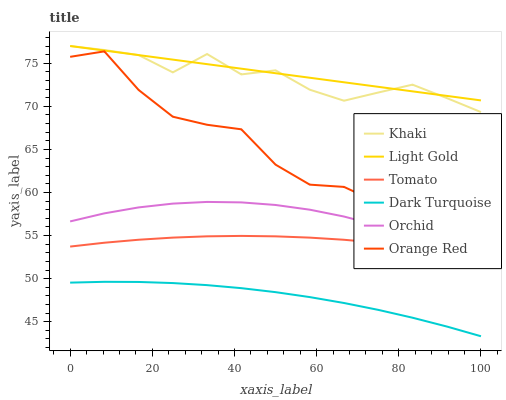Does Dark Turquoise have the minimum area under the curve?
Answer yes or no. Yes. Does Light Gold have the maximum area under the curve?
Answer yes or no. Yes. Does Khaki have the minimum area under the curve?
Answer yes or no. No. Does Khaki have the maximum area under the curve?
Answer yes or no. No. Is Light Gold the smoothest?
Answer yes or no. Yes. Is Orange Red the roughest?
Answer yes or no. Yes. Is Khaki the smoothest?
Answer yes or no. No. Is Khaki the roughest?
Answer yes or no. No. Does Dark Turquoise have the lowest value?
Answer yes or no. Yes. Does Khaki have the lowest value?
Answer yes or no. No. Does Light Gold have the highest value?
Answer yes or no. Yes. Does Dark Turquoise have the highest value?
Answer yes or no. No. Is Orchid less than Khaki?
Answer yes or no. Yes. Is Orange Red greater than Dark Turquoise?
Answer yes or no. Yes. Does Orange Red intersect Orchid?
Answer yes or no. Yes. Is Orange Red less than Orchid?
Answer yes or no. No. Is Orange Red greater than Orchid?
Answer yes or no. No. Does Orchid intersect Khaki?
Answer yes or no. No. 